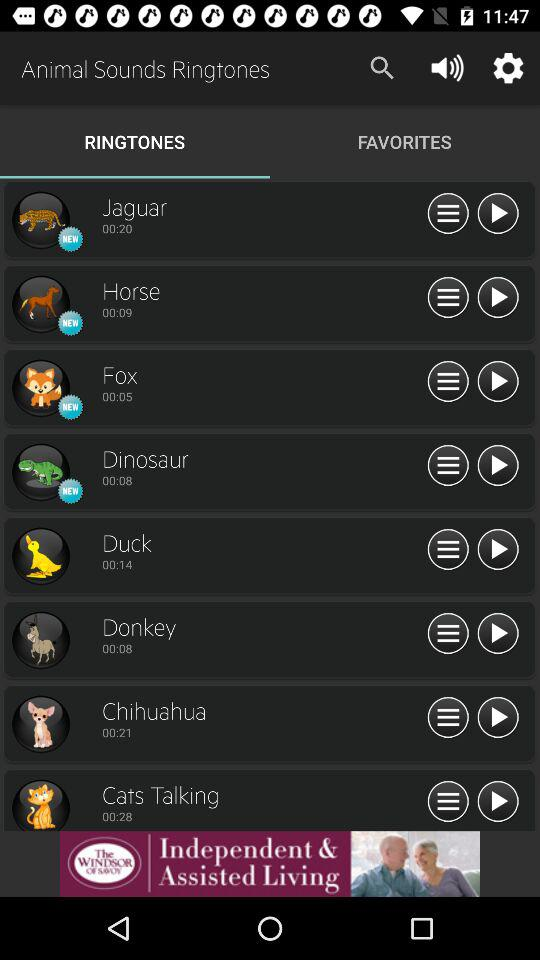How long is the "Duck" ringtone? The "Duck" ringtone is 14 seconds long. 